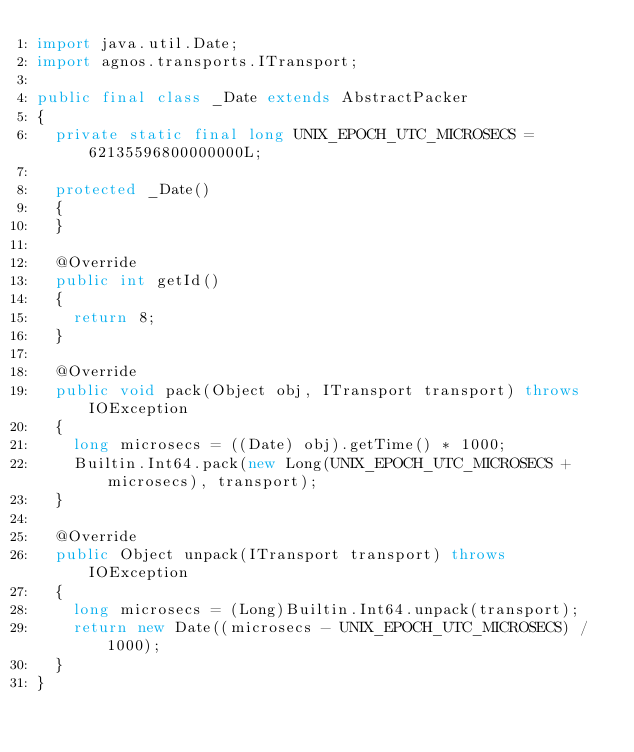Convert code to text. <code><loc_0><loc_0><loc_500><loc_500><_Java_>import java.util.Date;
import agnos.transports.ITransport;

public final class _Date extends AbstractPacker
{
	private static final long UNIX_EPOCH_UTC_MICROSECS = 62135596800000000L;
	
	protected _Date()
	{
	}

	@Override
	public int getId()
	{
		return 8;
	}
	
	@Override
	public void pack(Object obj, ITransport transport) throws IOException
	{
		long microsecs = ((Date) obj).getTime() * 1000;
		Builtin.Int64.pack(new Long(UNIX_EPOCH_UTC_MICROSECS + microsecs), transport);
	}

	@Override
	public Object unpack(ITransport transport) throws IOException
	{
		long microsecs = (Long)Builtin.Int64.unpack(transport);
		return new Date((microsecs - UNIX_EPOCH_UTC_MICROSECS) / 1000);
	}
}
</code> 